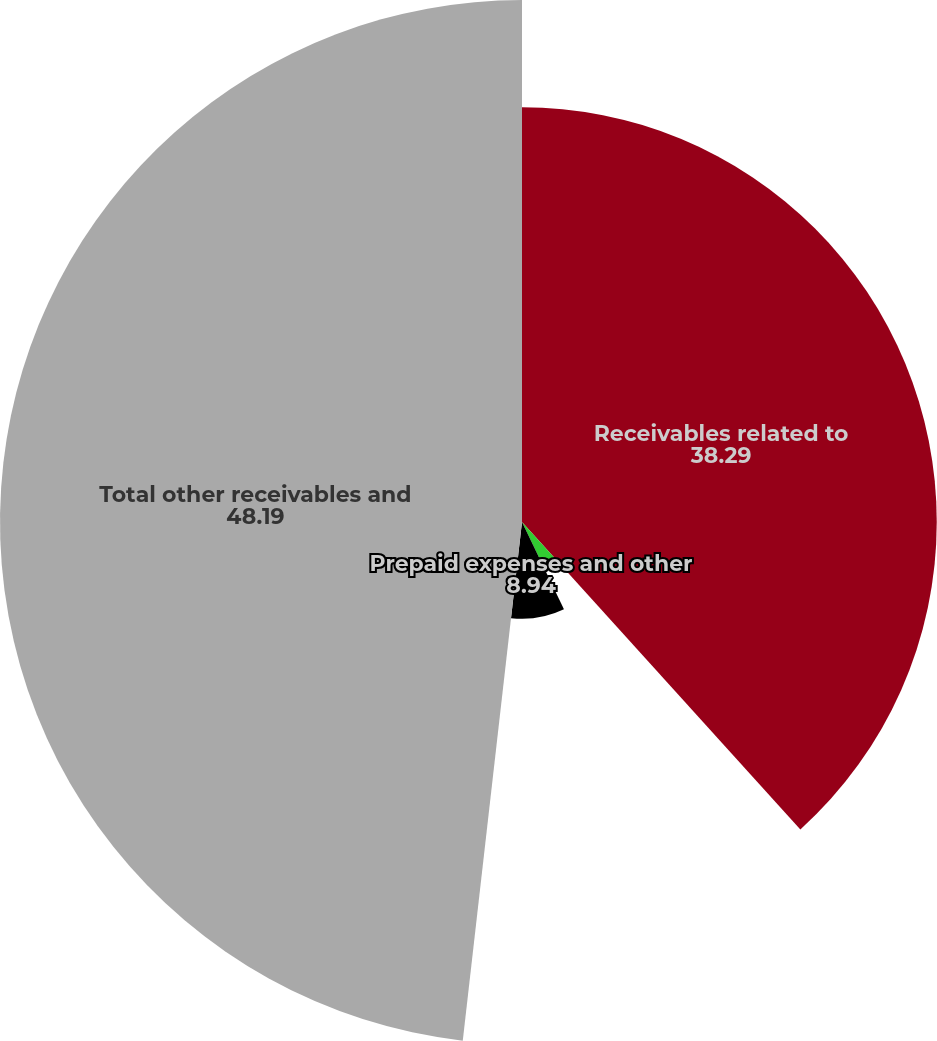Convert chart to OTSL. <chart><loc_0><loc_0><loc_500><loc_500><pie_chart><fcel>Receivables related to<fcel>Income taxes receivable<fcel>Prepaid expenses and other<fcel>Total other receivables and<nl><fcel>38.29%<fcel>4.58%<fcel>8.94%<fcel>48.19%<nl></chart> 